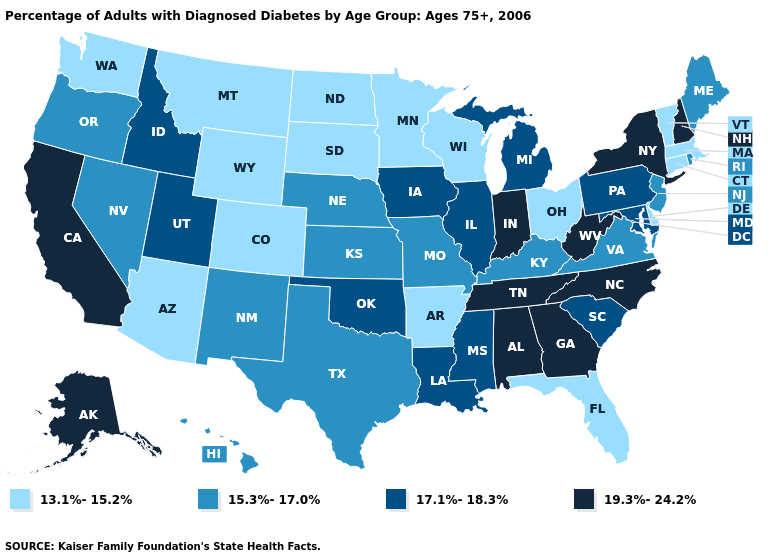Name the states that have a value in the range 19.3%-24.2%?
Concise answer only. Alabama, Alaska, California, Georgia, Indiana, New Hampshire, New York, North Carolina, Tennessee, West Virginia. How many symbols are there in the legend?
Quick response, please. 4. Name the states that have a value in the range 13.1%-15.2%?
Quick response, please. Arizona, Arkansas, Colorado, Connecticut, Delaware, Florida, Massachusetts, Minnesota, Montana, North Dakota, Ohio, South Dakota, Vermont, Washington, Wisconsin, Wyoming. Which states have the highest value in the USA?
Write a very short answer. Alabama, Alaska, California, Georgia, Indiana, New Hampshire, New York, North Carolina, Tennessee, West Virginia. What is the value of Arizona?
Write a very short answer. 13.1%-15.2%. What is the value of Texas?
Write a very short answer. 15.3%-17.0%. Does Alabama have the highest value in the South?
Write a very short answer. Yes. Does Massachusetts have the lowest value in the Northeast?
Short answer required. Yes. Among the states that border Ohio , which have the lowest value?
Write a very short answer. Kentucky. What is the lowest value in the USA?
Answer briefly. 13.1%-15.2%. Name the states that have a value in the range 19.3%-24.2%?
Give a very brief answer. Alabama, Alaska, California, Georgia, Indiana, New Hampshire, New York, North Carolina, Tennessee, West Virginia. Name the states that have a value in the range 15.3%-17.0%?
Short answer required. Hawaii, Kansas, Kentucky, Maine, Missouri, Nebraska, Nevada, New Jersey, New Mexico, Oregon, Rhode Island, Texas, Virginia. Which states have the lowest value in the South?
Be succinct. Arkansas, Delaware, Florida. What is the value of Kentucky?
Answer briefly. 15.3%-17.0%. Which states have the lowest value in the Northeast?
Be succinct. Connecticut, Massachusetts, Vermont. 